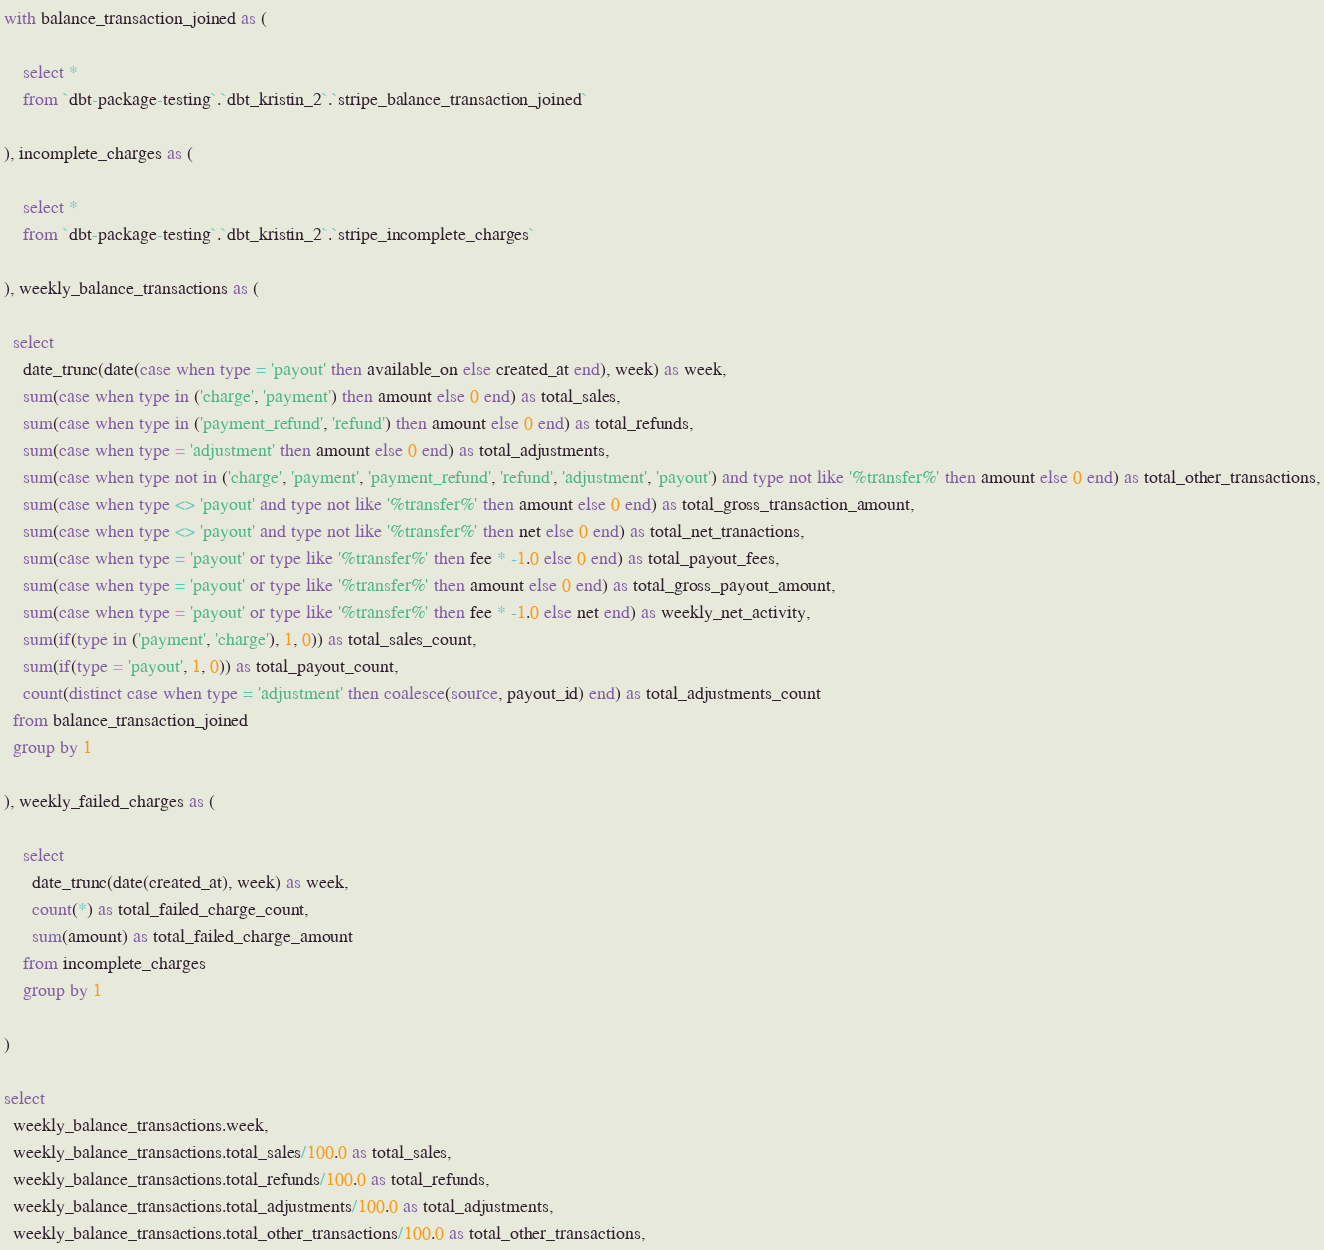<code> <loc_0><loc_0><loc_500><loc_500><_SQL_>with balance_transaction_joined as (

    select *
    from `dbt-package-testing`.`dbt_kristin_2`.`stripe_balance_transaction_joined`  

), incomplete_charges as (

    select *
    from `dbt-package-testing`.`dbt_kristin_2`.`stripe_incomplete_charges`  

), weekly_balance_transactions as (

  select
    date_trunc(date(case when type = 'payout' then available_on else created_at end), week) as week,
    sum(case when type in ('charge', 'payment') then amount else 0 end) as total_sales,
    sum(case when type in ('payment_refund', 'refund') then amount else 0 end) as total_refunds,
    sum(case when type = 'adjustment' then amount else 0 end) as total_adjustments,
    sum(case when type not in ('charge', 'payment', 'payment_refund', 'refund', 'adjustment', 'payout') and type not like '%transfer%' then amount else 0 end) as total_other_transactions,
    sum(case when type <> 'payout' and type not like '%transfer%' then amount else 0 end) as total_gross_transaction_amount,
    sum(case when type <> 'payout' and type not like '%transfer%' then net else 0 end) as total_net_tranactions,
    sum(case when type = 'payout' or type like '%transfer%' then fee * -1.0 else 0 end) as total_payout_fees,
    sum(case when type = 'payout' or type like '%transfer%' then amount else 0 end) as total_gross_payout_amount,
    sum(case when type = 'payout' or type like '%transfer%' then fee * -1.0 else net end) as weekly_net_activity,
    sum(if(type in ('payment', 'charge'), 1, 0)) as total_sales_count,
    sum(if(type = 'payout', 1, 0)) as total_payout_count,
    count(distinct case when type = 'adjustment' then coalesce(source, payout_id) end) as total_adjustments_count
  from balance_transaction_joined
  group by 1

), weekly_failed_charges as (

    select
      date_trunc(date(created_at), week) as week,
      count(*) as total_failed_charge_count,
      sum(amount) as total_failed_charge_amount
    from incomplete_charges
    group by 1

)

select
  weekly_balance_transactions.week,
  weekly_balance_transactions.total_sales/100.0 as total_sales,
  weekly_balance_transactions.total_refunds/100.0 as total_refunds,
  weekly_balance_transactions.total_adjustments/100.0 as total_adjustments,
  weekly_balance_transactions.total_other_transactions/100.0 as total_other_transactions,</code> 